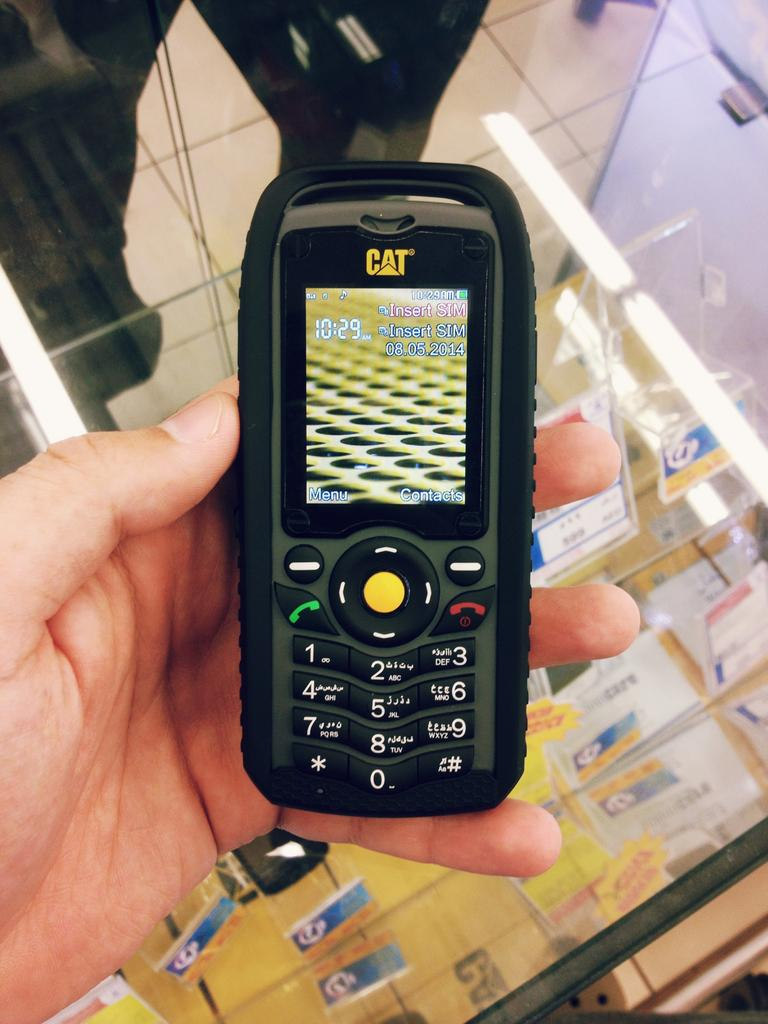<image>
Present a compact description of the photo's key features. Cellphone that reads 10:29 and needs a SIM card inserted. 